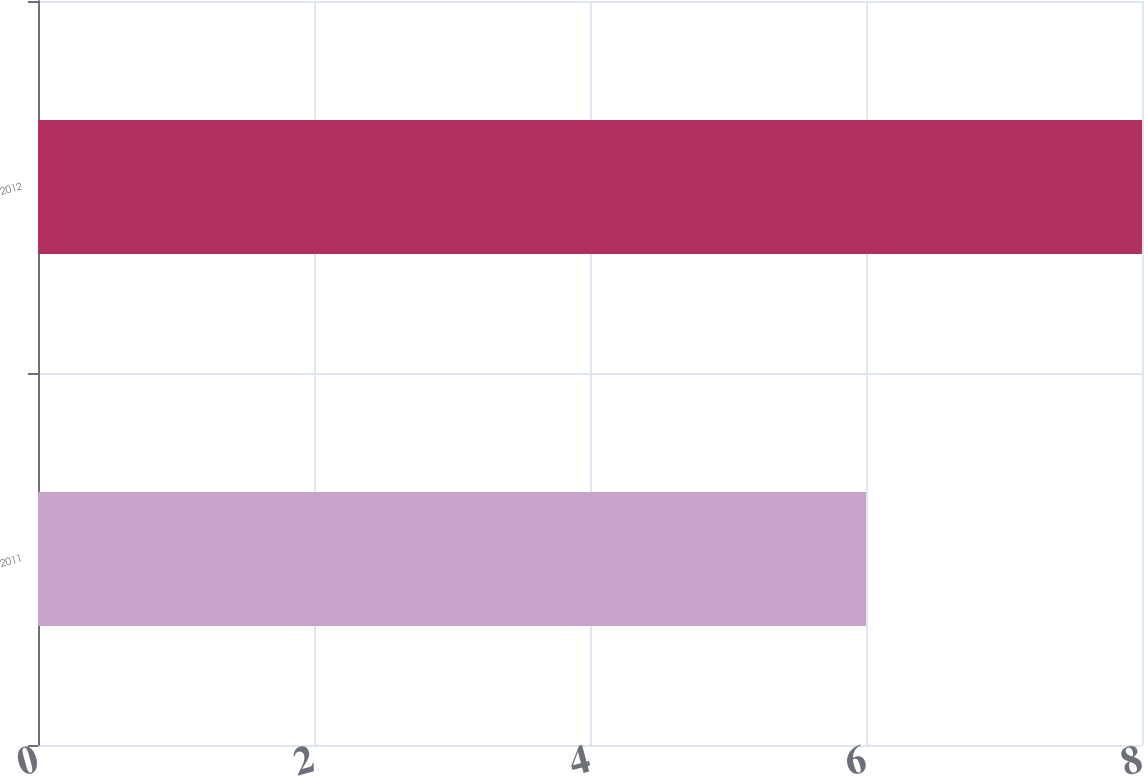Convert chart. <chart><loc_0><loc_0><loc_500><loc_500><bar_chart><fcel>2011<fcel>2012<nl><fcel>6<fcel>8<nl></chart> 